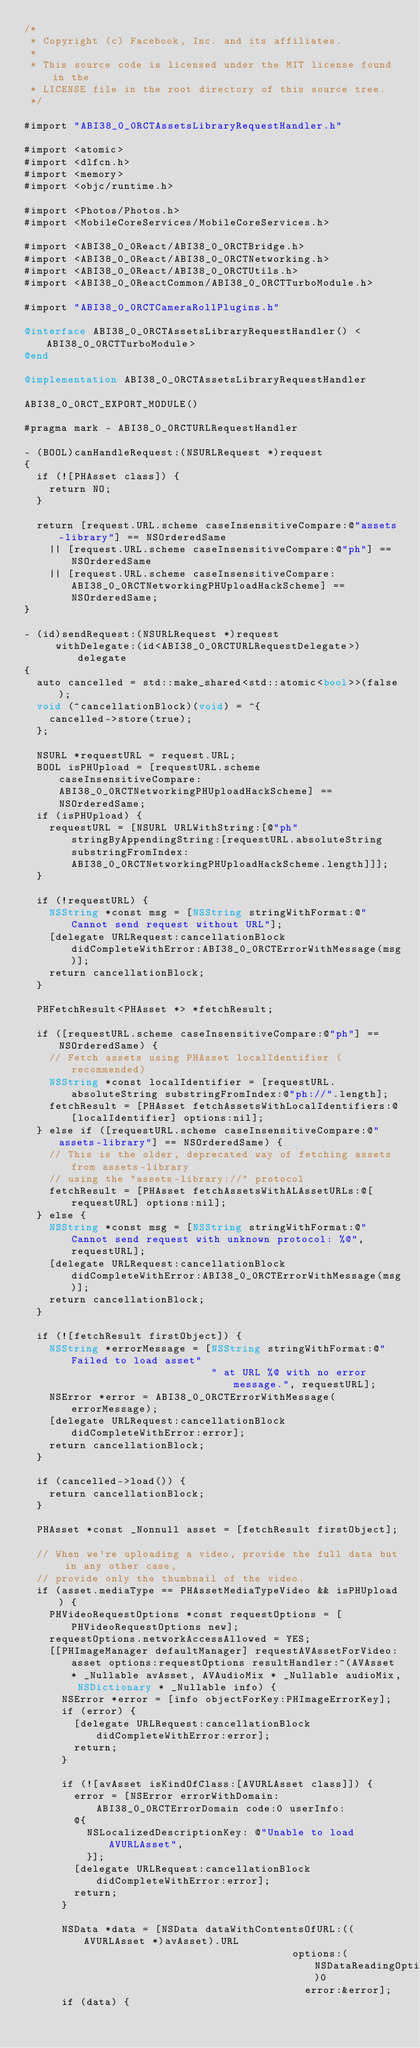<code> <loc_0><loc_0><loc_500><loc_500><_ObjectiveC_>/*
 * Copyright (c) Facebook, Inc. and its affiliates.
 *
 * This source code is licensed under the MIT license found in the
 * LICENSE file in the root directory of this source tree.
 */

#import "ABI38_0_0RCTAssetsLibraryRequestHandler.h"

#import <atomic>
#import <dlfcn.h>
#import <memory>
#import <objc/runtime.h>

#import <Photos/Photos.h>
#import <MobileCoreServices/MobileCoreServices.h>

#import <ABI38_0_0React/ABI38_0_0RCTBridge.h>
#import <ABI38_0_0React/ABI38_0_0RCTNetworking.h>
#import <ABI38_0_0React/ABI38_0_0RCTUtils.h>
#import <ABI38_0_0ReactCommon/ABI38_0_0RCTTurboModule.h>

#import "ABI38_0_0RCTCameraRollPlugins.h"

@interface ABI38_0_0RCTAssetsLibraryRequestHandler() <ABI38_0_0RCTTurboModule>
@end

@implementation ABI38_0_0RCTAssetsLibraryRequestHandler

ABI38_0_0RCT_EXPORT_MODULE()

#pragma mark - ABI38_0_0RCTURLRequestHandler

- (BOOL)canHandleRequest:(NSURLRequest *)request
{
  if (![PHAsset class]) {
    return NO;
  }

  return [request.URL.scheme caseInsensitiveCompare:@"assets-library"] == NSOrderedSame
    || [request.URL.scheme caseInsensitiveCompare:@"ph"] == NSOrderedSame
    || [request.URL.scheme caseInsensitiveCompare:ABI38_0_0RCTNetworkingPHUploadHackScheme] == NSOrderedSame;
}

- (id)sendRequest:(NSURLRequest *)request
     withDelegate:(id<ABI38_0_0RCTURLRequestDelegate>)delegate
{
  auto cancelled = std::make_shared<std::atomic<bool>>(false);
  void (^cancellationBlock)(void) = ^{
    cancelled->store(true);
  };

  NSURL *requestURL = request.URL;
  BOOL isPHUpload = [requestURL.scheme caseInsensitiveCompare:ABI38_0_0RCTNetworkingPHUploadHackScheme] == NSOrderedSame;
  if (isPHUpload) {
    requestURL = [NSURL URLWithString:[@"ph" stringByAppendingString:[requestURL.absoluteString substringFromIndex:ABI38_0_0RCTNetworkingPHUploadHackScheme.length]]];
  }

  if (!requestURL) {
    NSString *const msg = [NSString stringWithFormat:@"Cannot send request without URL"];
    [delegate URLRequest:cancellationBlock didCompleteWithError:ABI38_0_0RCTErrorWithMessage(msg)];
    return cancellationBlock;
  }

  PHFetchResult<PHAsset *> *fetchResult;

  if ([requestURL.scheme caseInsensitiveCompare:@"ph"] == NSOrderedSame) {
    // Fetch assets using PHAsset localIdentifier (recommended)
    NSString *const localIdentifier = [requestURL.absoluteString substringFromIndex:@"ph://".length];
    fetchResult = [PHAsset fetchAssetsWithLocalIdentifiers:@[localIdentifier] options:nil];
  } else if ([requestURL.scheme caseInsensitiveCompare:@"assets-library"] == NSOrderedSame) {
    // This is the older, deprecated way of fetching assets from assets-library
    // using the "assets-library://" protocol
    fetchResult = [PHAsset fetchAssetsWithALAssetURLs:@[requestURL] options:nil];
  } else {
    NSString *const msg = [NSString stringWithFormat:@"Cannot send request with unknown protocol: %@", requestURL];
    [delegate URLRequest:cancellationBlock didCompleteWithError:ABI38_0_0RCTErrorWithMessage(msg)];
    return cancellationBlock;
  }

  if (![fetchResult firstObject]) {
    NSString *errorMessage = [NSString stringWithFormat:@"Failed to load asset"
                              " at URL %@ with no error message.", requestURL];
    NSError *error = ABI38_0_0RCTErrorWithMessage(errorMessage);
    [delegate URLRequest:cancellationBlock didCompleteWithError:error];
    return cancellationBlock;
  }

  if (cancelled->load()) {
    return cancellationBlock;
  }

  PHAsset *const _Nonnull asset = [fetchResult firstObject];

  // When we're uploading a video, provide the full data but in any other case,
  // provide only the thumbnail of the video.
  if (asset.mediaType == PHAssetMediaTypeVideo && isPHUpload) {
    PHVideoRequestOptions *const requestOptions = [PHVideoRequestOptions new];
    requestOptions.networkAccessAllowed = YES;
    [[PHImageManager defaultManager] requestAVAssetForVideo:asset options:requestOptions resultHandler:^(AVAsset * _Nullable avAsset, AVAudioMix * _Nullable audioMix, NSDictionary * _Nullable info) {
      NSError *error = [info objectForKey:PHImageErrorKey];
      if (error) {
        [delegate URLRequest:cancellationBlock didCompleteWithError:error];
        return;
      }

      if (![avAsset isKindOfClass:[AVURLAsset class]]) {
        error = [NSError errorWithDomain:ABI38_0_0RCTErrorDomain code:0 userInfo:
        @{
          NSLocalizedDescriptionKey: @"Unable to load AVURLAsset",
          }];
        [delegate URLRequest:cancellationBlock didCompleteWithError:error];
        return;
      }

      NSData *data = [NSData dataWithContentsOfURL:((AVURLAsset *)avAsset).URL
                                           options:(NSDataReadingOptions)0
                                             error:&error];
      if (data) {</code> 